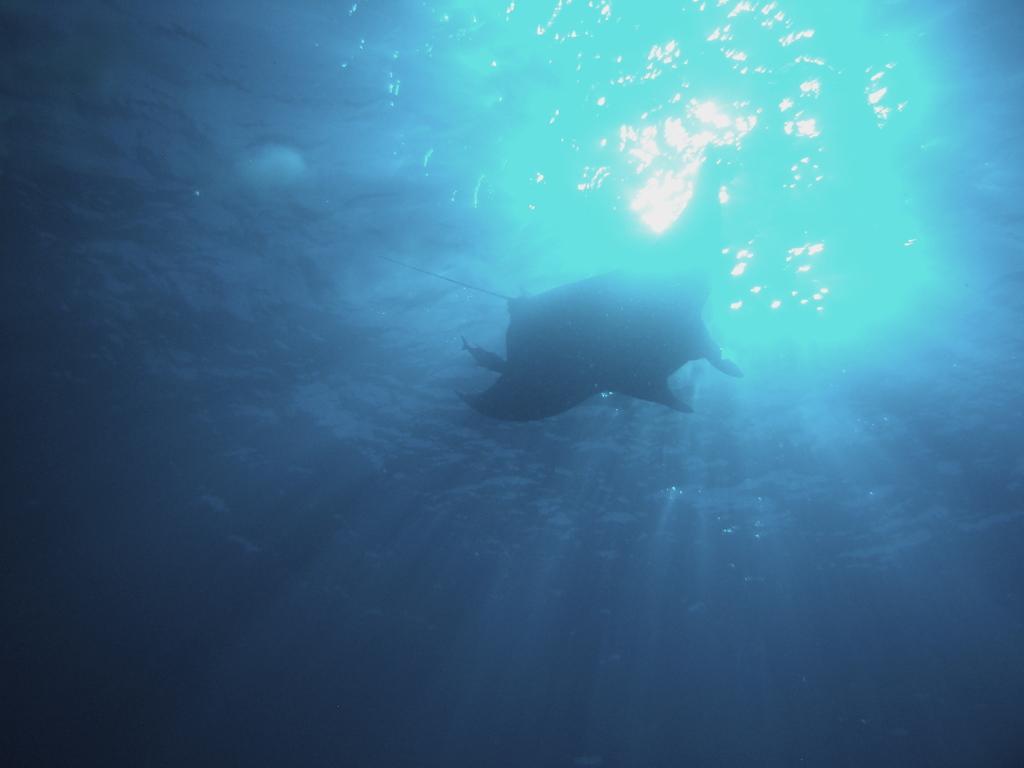In one or two sentences, can you explain what this image depicts? In this image we can see fishes in the water. 